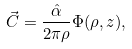Convert formula to latex. <formula><loc_0><loc_0><loc_500><loc_500>\vec { C } = \frac { \hat { \alpha } } { 2 \pi \rho } \Phi ( \rho , z ) ,</formula> 